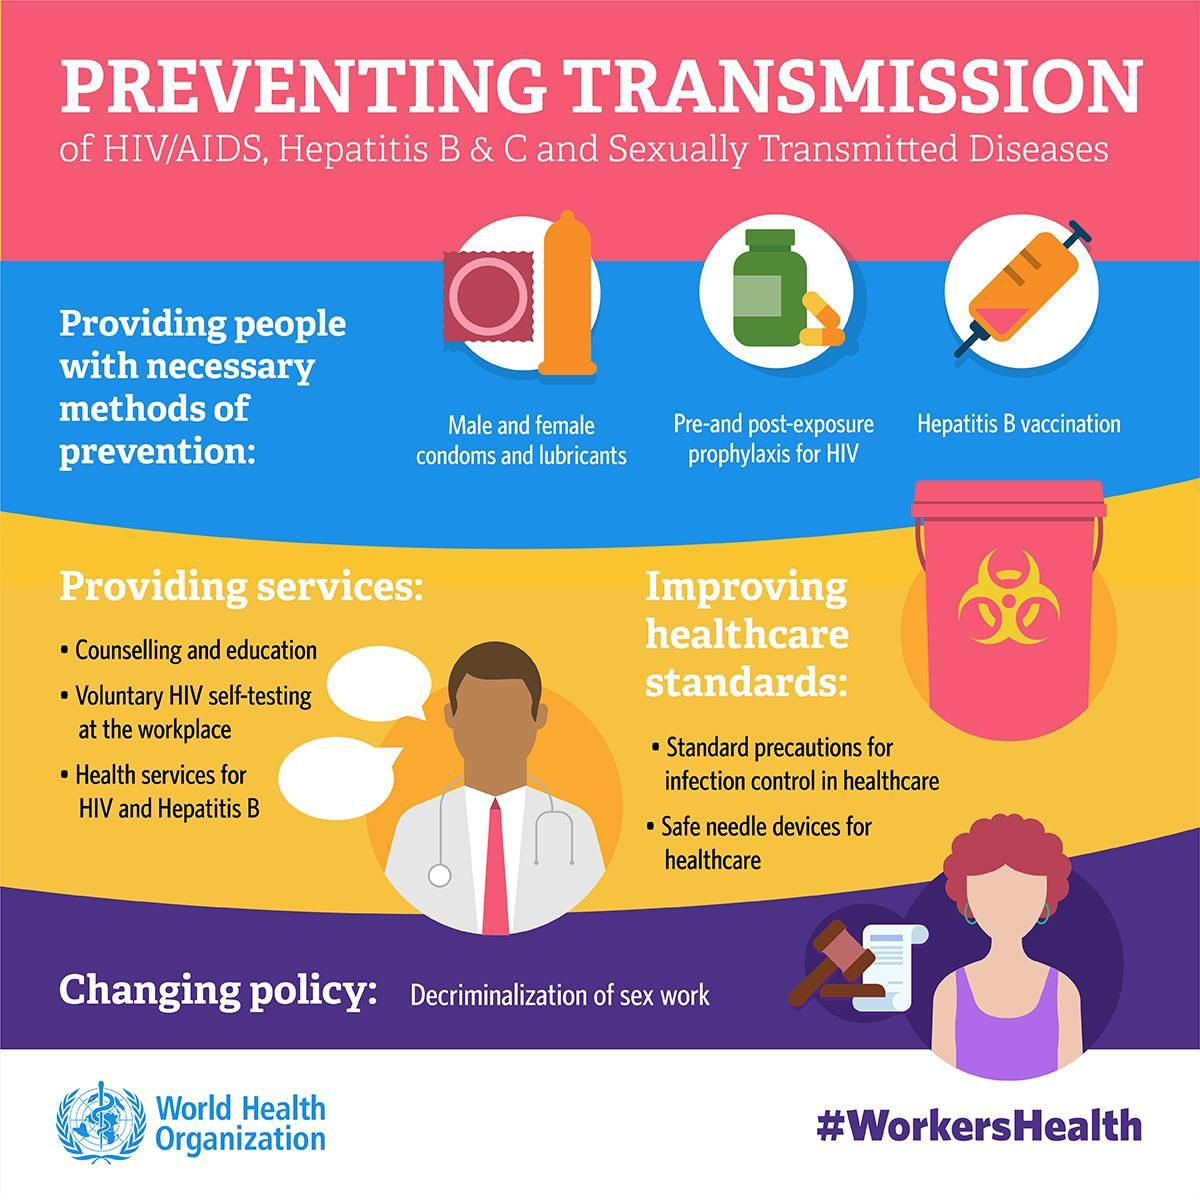How many services have been highlighted
Answer the question with a short phrase. 3 How can healthcare standards be improved standard precautions for infection control in healthcare, safe needle devices for healthcare How many ways of prevents are shown 3 